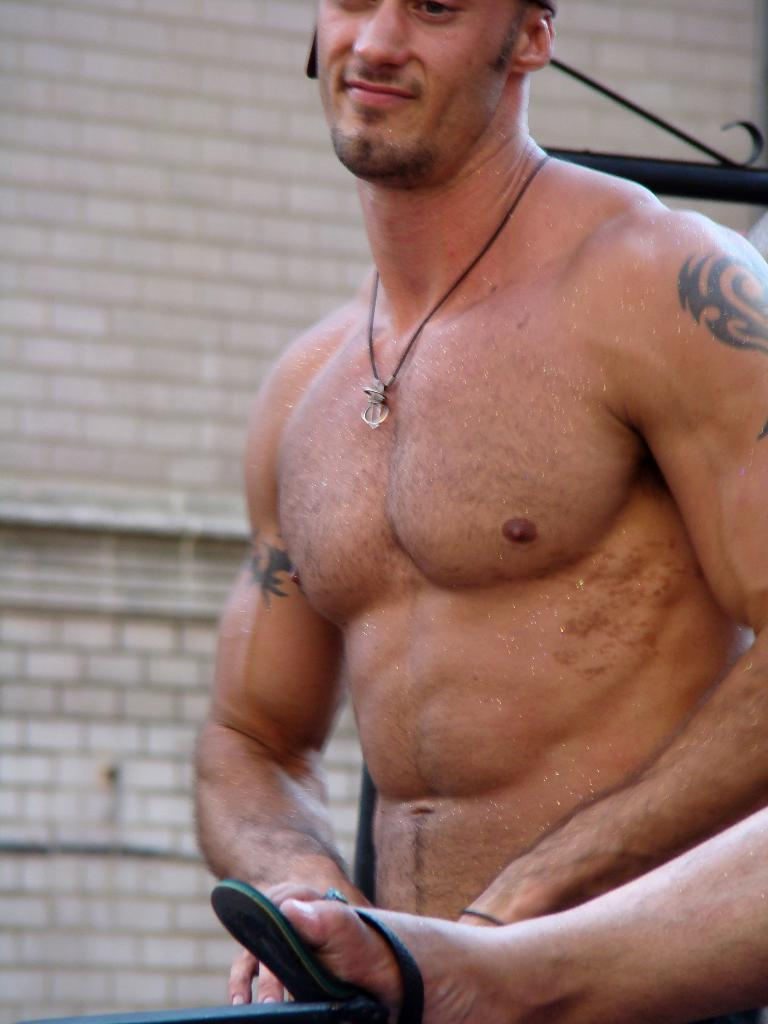Who is present in the image? There is a man in the image. What part of a person can be seen in the image? A leg of a person is visible in the image. What can be seen in the background of the image? There is a wall in the background of the image. What type of sponge is being used by the mother in the image? There is no sponge or mother present in the image. What is the temperature like in the image? The provided facts do not mention the temperature or heat in the image. 